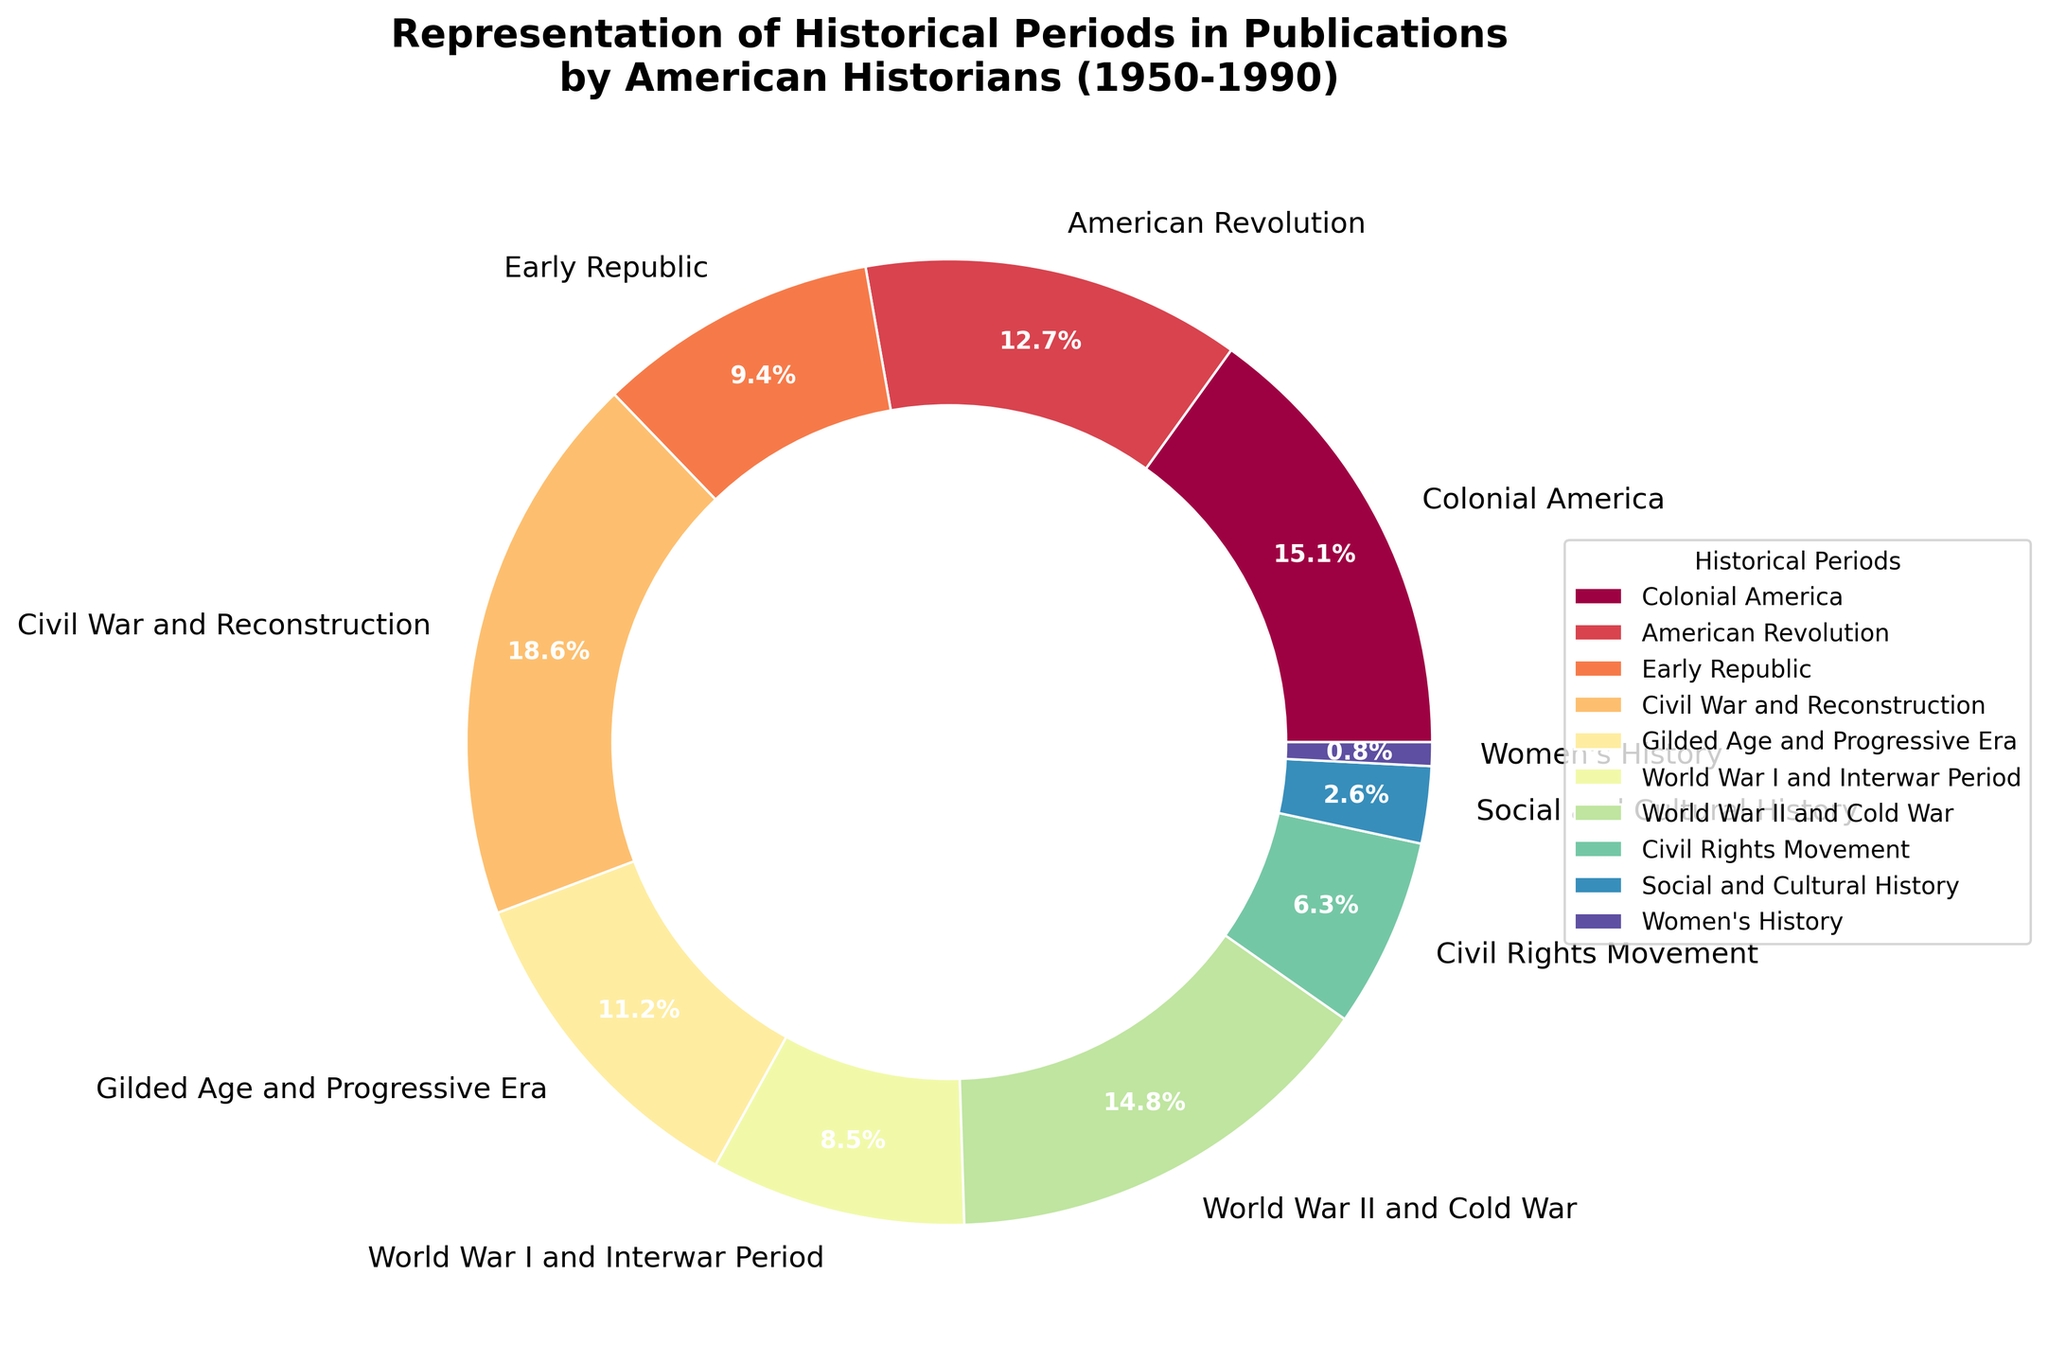What's the total percentage of publications dealing with wars (Revolutionary, Civil War, World War I & Interwar, World War II & Cold War)? Add the percentages of the American Revolution, Civil War and Reconstruction, World War I and Interwar Period, and World War II and Cold War: 12.8% + 18.7% + 8.6% + 14.9% = 55%.
Answer: 55% Which period has the highest representation in the publications? Compare the percentages of each historical period. The highest percentage is for the Civil War and Reconstruction period at 18.7%.
Answer: Civil War and Reconstruction What is the difference in representation between the Gilded Age and Progressive Era and the Civil Rights Movement? Subtract the percentage of the Civil Rights Movement from the percentage of the Gilded Age and Progressive Era: 11.3% - 6.4% = 4.9%.
Answer: 4.9% How do the percentages of the Early Republic and Women's History compare? The Early Republic has 9.5%, while Women's History has 0.8%. The Early Republic has a higher percentage.
Answer: Early Republic > Women's History What historical period has a representation closest to 15%? Compare all the percentages to 15%. The closest is the Colonial America period with 15.2%.
Answer: Colonial America Which period is represented less frequently than Social and Cultural History? Women's History at 0.8% is less than Social and Cultural History at 2.6%.
Answer: Women's History What is the cumulative representation of the Early Republic, Gilded Age and Progressive Era, and Civil Rights Movement? Add the percentages of the Early Republic, Gilded Age and Progressive Era, and Civil Rights Movement: 9.5% + 11.3% + 6.4% = 27.2%.
Answer: 27.2% How does the representation of the American Revolution compare to the Colonial America period? American Revolution is 12.8%, Colonial America is 15.2%. Colonial America has a higher representation.
Answer: Colonial America > American Revolution What is the average representation percentage of the periods with less than 10% representation? Sum the percentages of periods with less than 10%: Early Republic (9.5) + World War I and Interwar Period (8.6) + Civil Rights Movement (6.4) + Social and Cultural History (2.6) + Women's History (0.8) = 27.9%. The total number of periods is 5. Therefore, the average is 27.9 / 5 = 5.58%.
Answer: 5.58% What is the sum of the percentages of the World Wars (World War I and Interwar Period and World War II and Cold War)? Sum the percentages of World War I and Interwar Period and World War II and Cold War: 8.6% + 14.9% = 23.5%.
Answer: 23.5% 